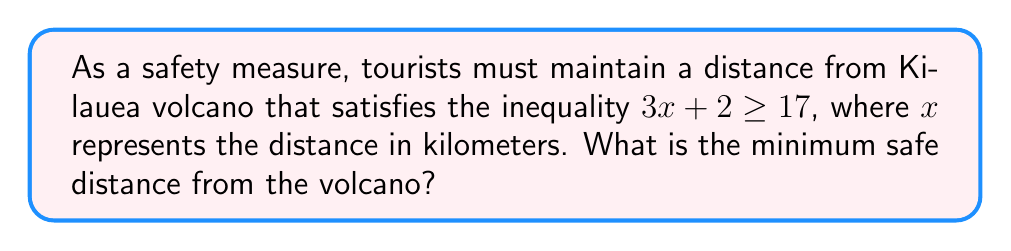What is the answer to this math problem? Let's solve this step-by-step:

1) We start with the inequality:
   $3x + 2 \geq 17$

2) To isolate $x$, first subtract 2 from both sides:
   $3x \geq 15$

3) Now, divide both sides by 3:
   $x \geq 5$

4) This means that $x$, the distance from the volcano, must be greater than or equal to 5 kilometers.

5) Therefore, the minimum safe distance is 5 kilometers.

This ensures that tourists are at a safe distance from Kilauea's potential lava flows and other volcanic hazards while still being able to appreciate the majestic beauty of the volcano.
Answer: 5 km 